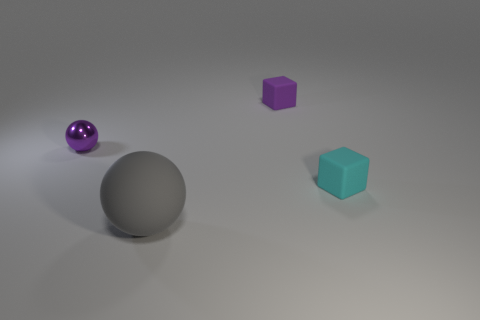Subtract 1 cubes. How many cubes are left? 1 Add 4 large red matte cylinders. How many objects exist? 8 Add 4 small purple shiny things. How many small purple shiny things exist? 5 Subtract 0 brown cylinders. How many objects are left? 4 Subtract all purple spheres. Subtract all cyan cylinders. How many spheres are left? 1 Subtract all purple balls. How many gray blocks are left? 0 Subtract all large gray matte things. Subtract all large things. How many objects are left? 2 Add 4 small cyan objects. How many small cyan objects are left? 5 